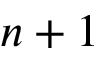<formula> <loc_0><loc_0><loc_500><loc_500>n + 1</formula> 